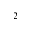<formula> <loc_0><loc_0><loc_500><loc_500>_ { 2 }</formula> 